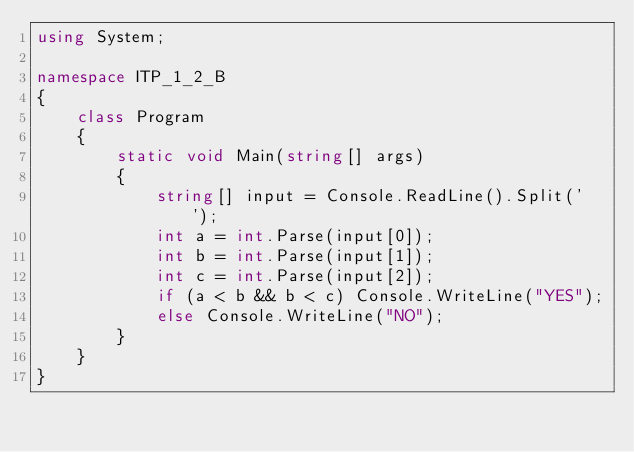Convert code to text. <code><loc_0><loc_0><loc_500><loc_500><_C#_>using System;

namespace ITP_1_2_B
{
    class Program
    {
        static void Main(string[] args)
        {
            string[] input = Console.ReadLine().Split(' ');
            int a = int.Parse(input[0]);
            int b = int.Parse(input[1]);
            int c = int.Parse(input[2]);
            if (a < b && b < c) Console.WriteLine("YES");
            else Console.WriteLine("NO");
        }
    }
}

</code> 